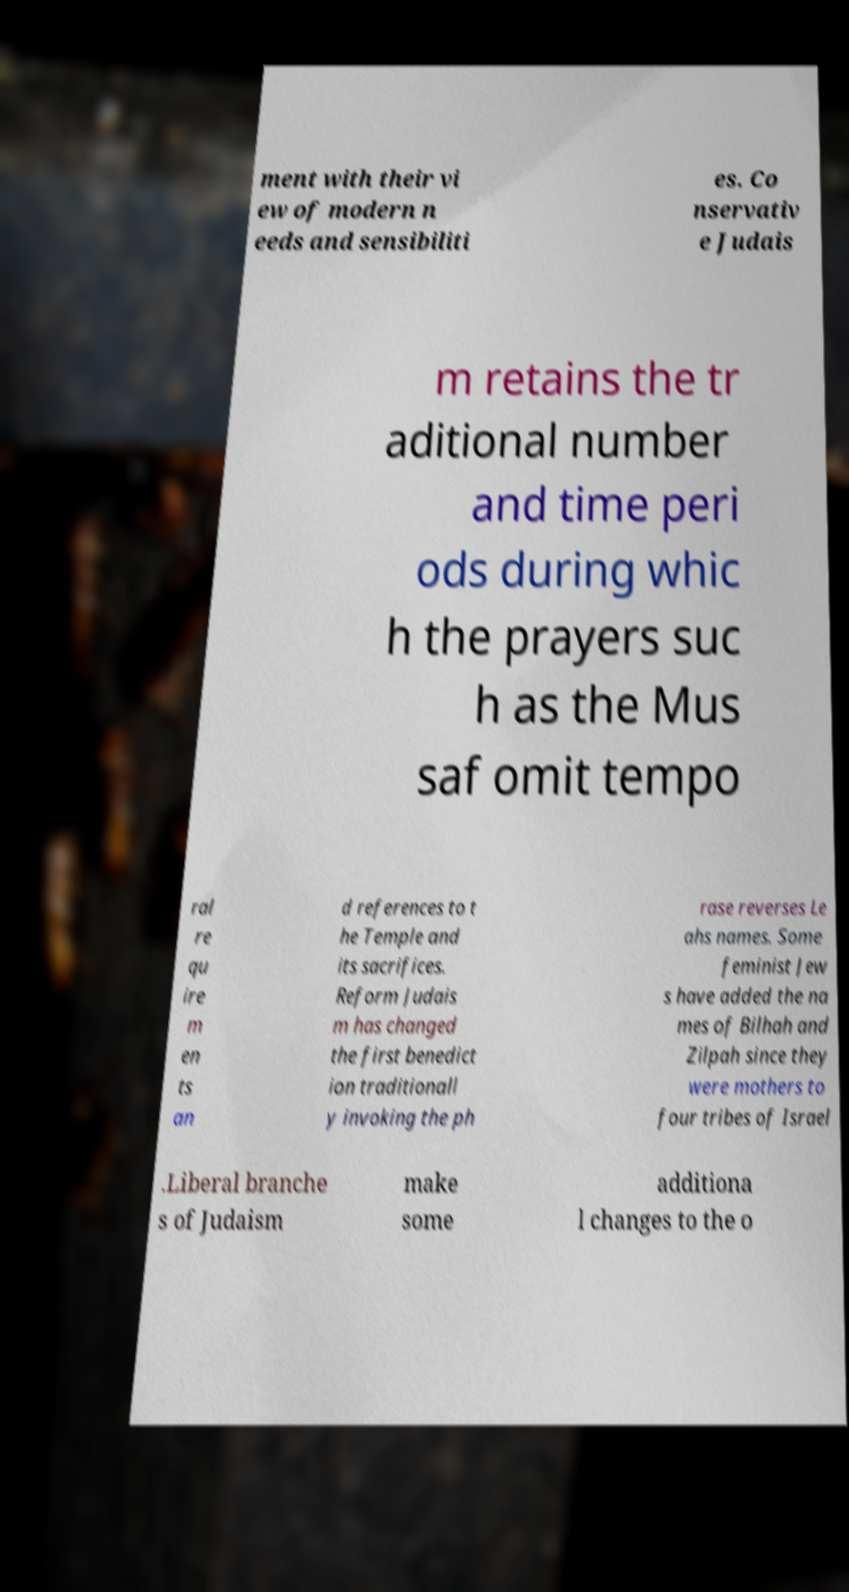What messages or text are displayed in this image? I need them in a readable, typed format. ment with their vi ew of modern n eeds and sensibiliti es. Co nservativ e Judais m retains the tr aditional number and time peri ods during whic h the prayers suc h as the Mus saf omit tempo ral re qu ire m en ts an d references to t he Temple and its sacrifices. Reform Judais m has changed the first benedict ion traditionall y invoking the ph rase reverses Le ahs names. Some feminist Jew s have added the na mes of Bilhah and Zilpah since they were mothers to four tribes of Israel .Liberal branche s of Judaism make some additiona l changes to the o 